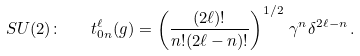Convert formula to latex. <formula><loc_0><loc_0><loc_500><loc_500>S U ( 2 ) \colon \quad t ^ { \ell } _ { 0 n } ( g ) = \left ( \frac { ( 2 \ell ) ! } { n ! { ( 2 \ell - n ) ! } } \right ) ^ { 1 / 2 } \, \gamma ^ { n } \delta ^ { 2 \ell - n } \, .</formula> 